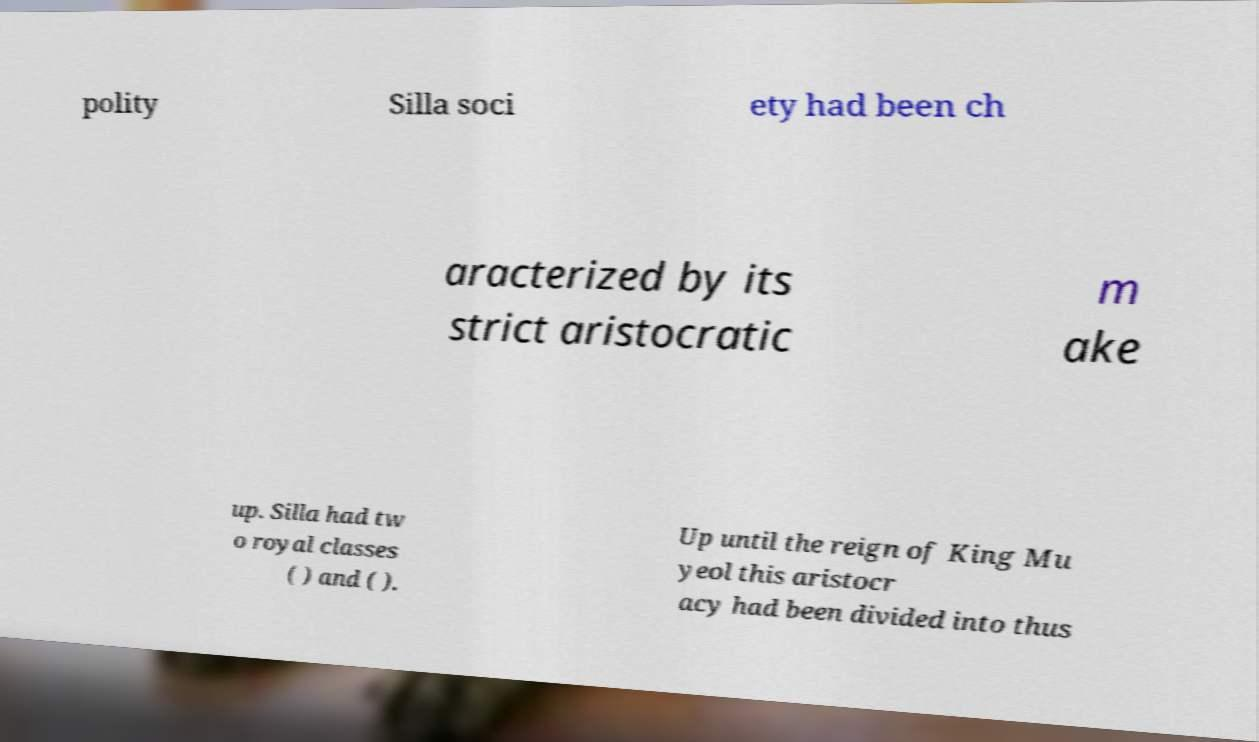There's text embedded in this image that I need extracted. Can you transcribe it verbatim? polity Silla soci ety had been ch aracterized by its strict aristocratic m ake up. Silla had tw o royal classes ( ) and ( ). Up until the reign of King Mu yeol this aristocr acy had been divided into thus 